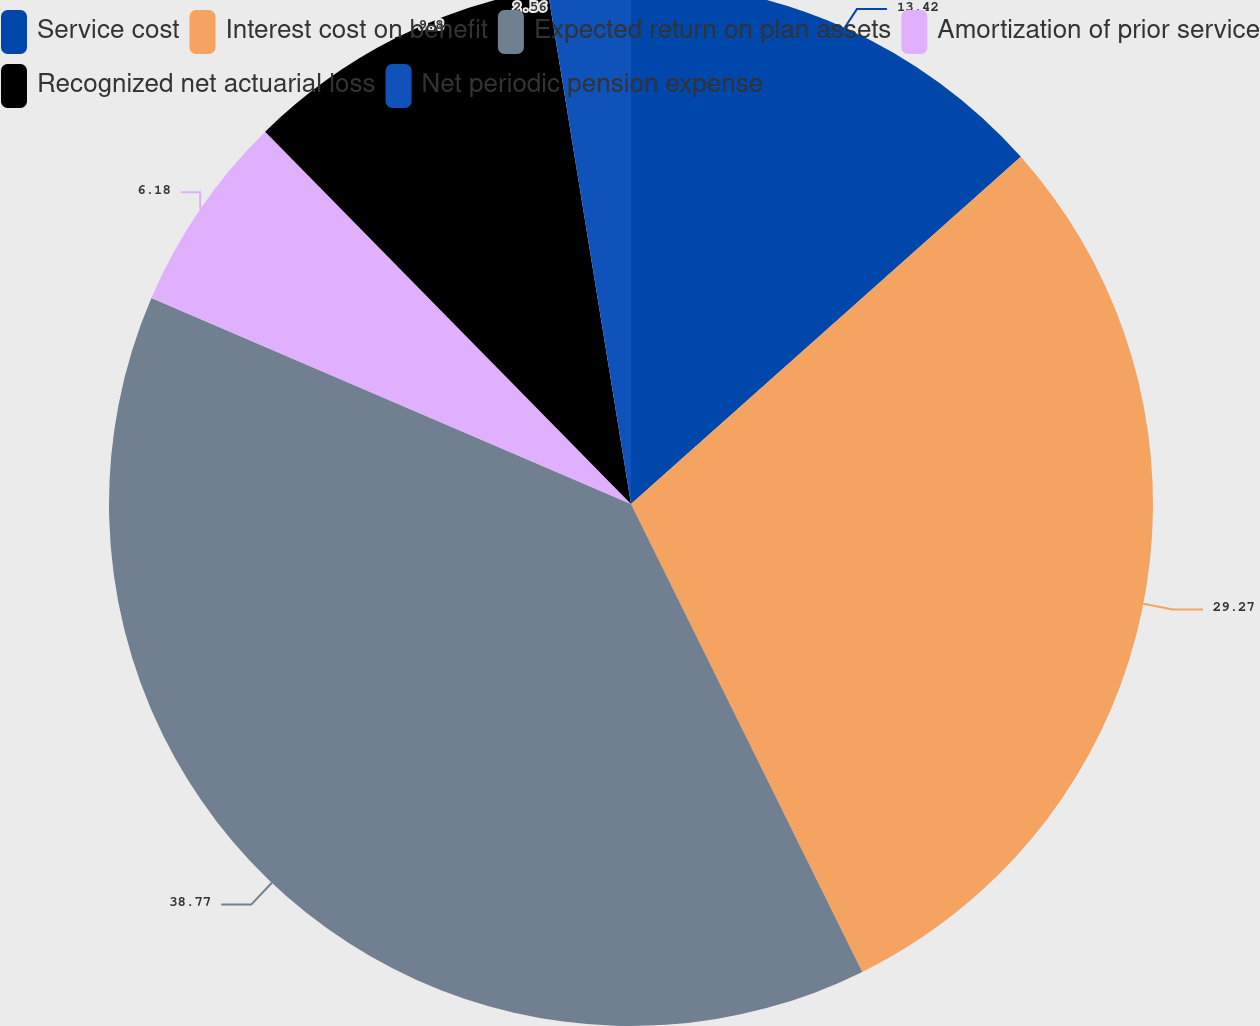Convert chart to OTSL. <chart><loc_0><loc_0><loc_500><loc_500><pie_chart><fcel>Service cost<fcel>Interest cost on benefit<fcel>Expected return on plan assets<fcel>Amortization of prior service<fcel>Recognized net actuarial loss<fcel>Net periodic pension expense<nl><fcel>13.42%<fcel>29.27%<fcel>38.76%<fcel>6.18%<fcel>9.8%<fcel>2.56%<nl></chart> 